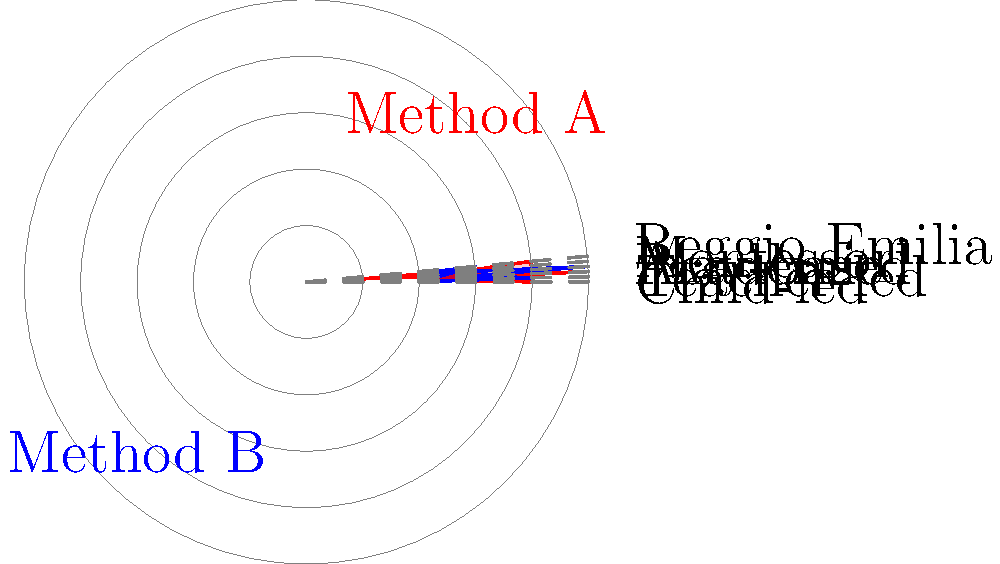Based on the radar chart comparing two early childhood education teaching methods, which method places a stronger emphasis on academic-focused learning? To answer this question, we need to analyze the radar chart and compare the values for the "Academic" component for both methods:

1. Identify the "Academic" axis on the chart (it's at the bottom right).
2. Compare the values for Method A (red) and Method B (blue) on this axis:
   - Method A: The value is close to 1 on the Academic axis.
   - Method B: The value is close to 5 on the Academic axis.
3. A higher value indicates a stronger emphasis on that particular aspect of teaching.
4. Since Method B has a higher value (5) compared to Method A (1) on the Academic axis, it places a stronger emphasis on academic-focused learning.

This chart also reveals other interesting comparisons:
- Method A is stronger in child-led and play-based approaches.
- Method B is stronger in teacher-led and academic approaches.
- Both methods have similar emphasis on Reggio Emilia approach.
- Method A has a slightly stronger emphasis on Montessori approach.

However, the question specifically asks about the academic focus, so we concentrate on that aspect for our answer.
Answer: Method B 